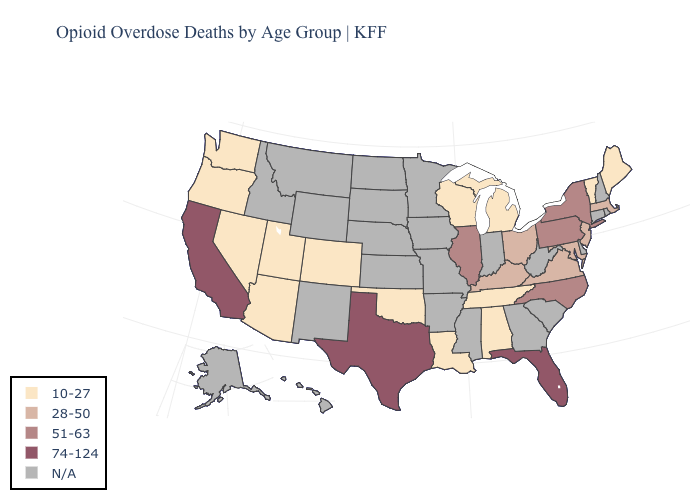Which states have the highest value in the USA?
Quick response, please. California, Florida, Texas. How many symbols are there in the legend?
Be succinct. 5. Name the states that have a value in the range 10-27?
Write a very short answer. Alabama, Arizona, Colorado, Louisiana, Maine, Michigan, Nevada, Oklahoma, Oregon, Tennessee, Utah, Vermont, Washington, Wisconsin. What is the lowest value in states that border California?
Write a very short answer. 10-27. What is the value of Iowa?
Be succinct. N/A. What is the lowest value in states that border Arkansas?
Quick response, please. 10-27. What is the value of Florida?
Answer briefly. 74-124. Does the map have missing data?
Concise answer only. Yes. Name the states that have a value in the range 74-124?
Concise answer only. California, Florida, Texas. Which states hav the highest value in the West?
Answer briefly. California. What is the highest value in states that border Connecticut?
Be succinct. 51-63. Among the states that border Texas , which have the lowest value?
Be succinct. Louisiana, Oklahoma. What is the value of Pennsylvania?
Short answer required. 51-63. 